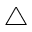<formula> <loc_0><loc_0><loc_500><loc_500>\bigtriangleup</formula> 